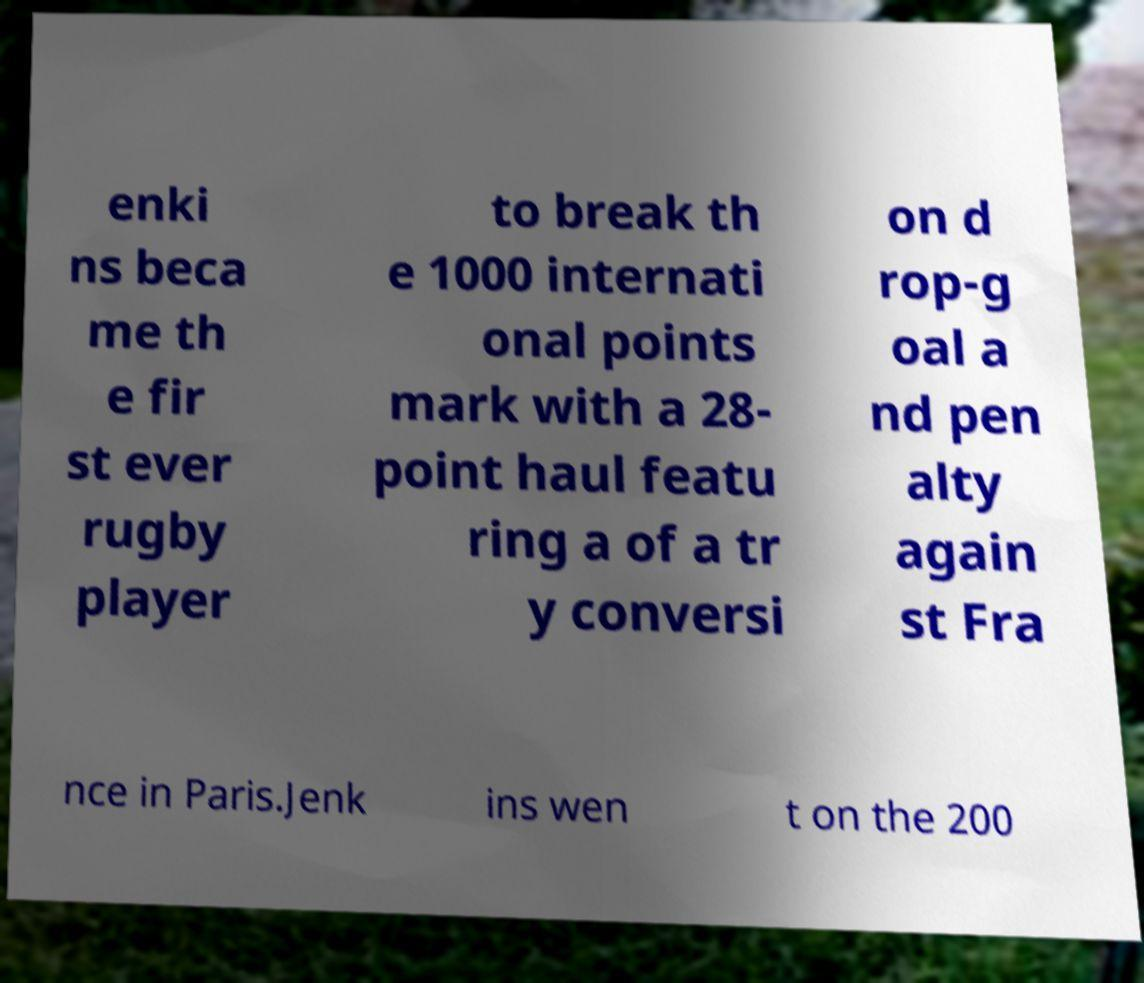Please identify and transcribe the text found in this image. enki ns beca me th e fir st ever rugby player to break th e 1000 internati onal points mark with a 28- point haul featu ring a of a tr y conversi on d rop-g oal a nd pen alty again st Fra nce in Paris.Jenk ins wen t on the 200 